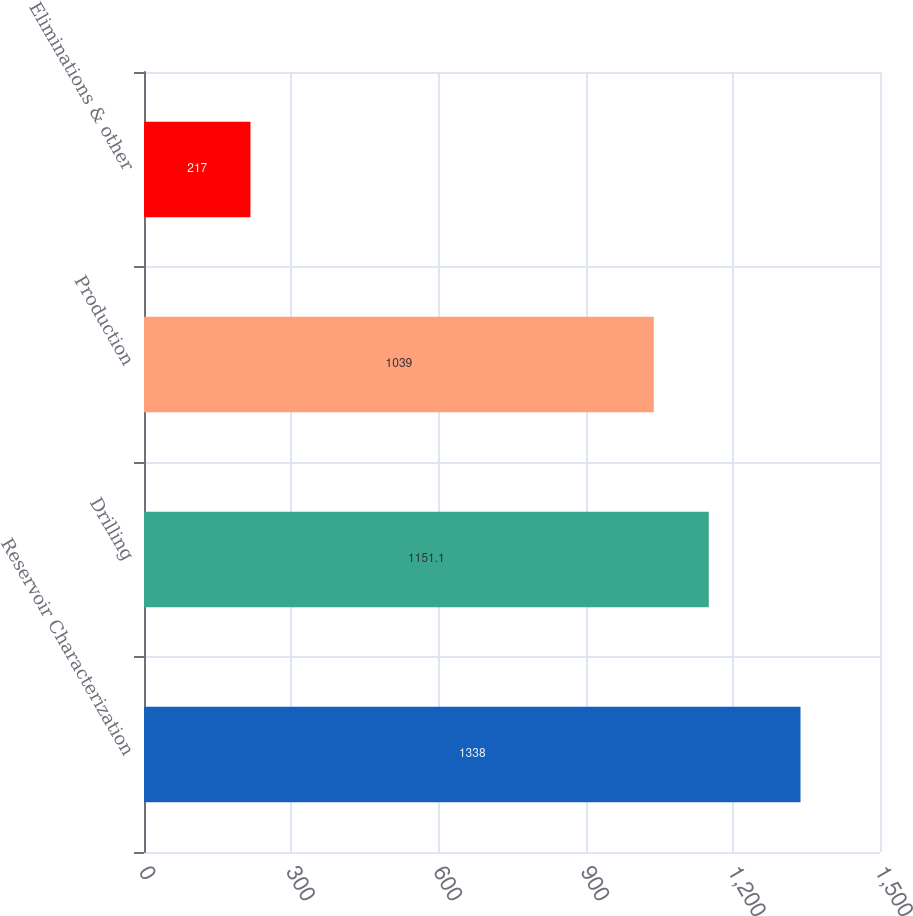Convert chart. <chart><loc_0><loc_0><loc_500><loc_500><bar_chart><fcel>Reservoir Characterization<fcel>Drilling<fcel>Production<fcel>Eliminations & other<nl><fcel>1338<fcel>1151.1<fcel>1039<fcel>217<nl></chart> 